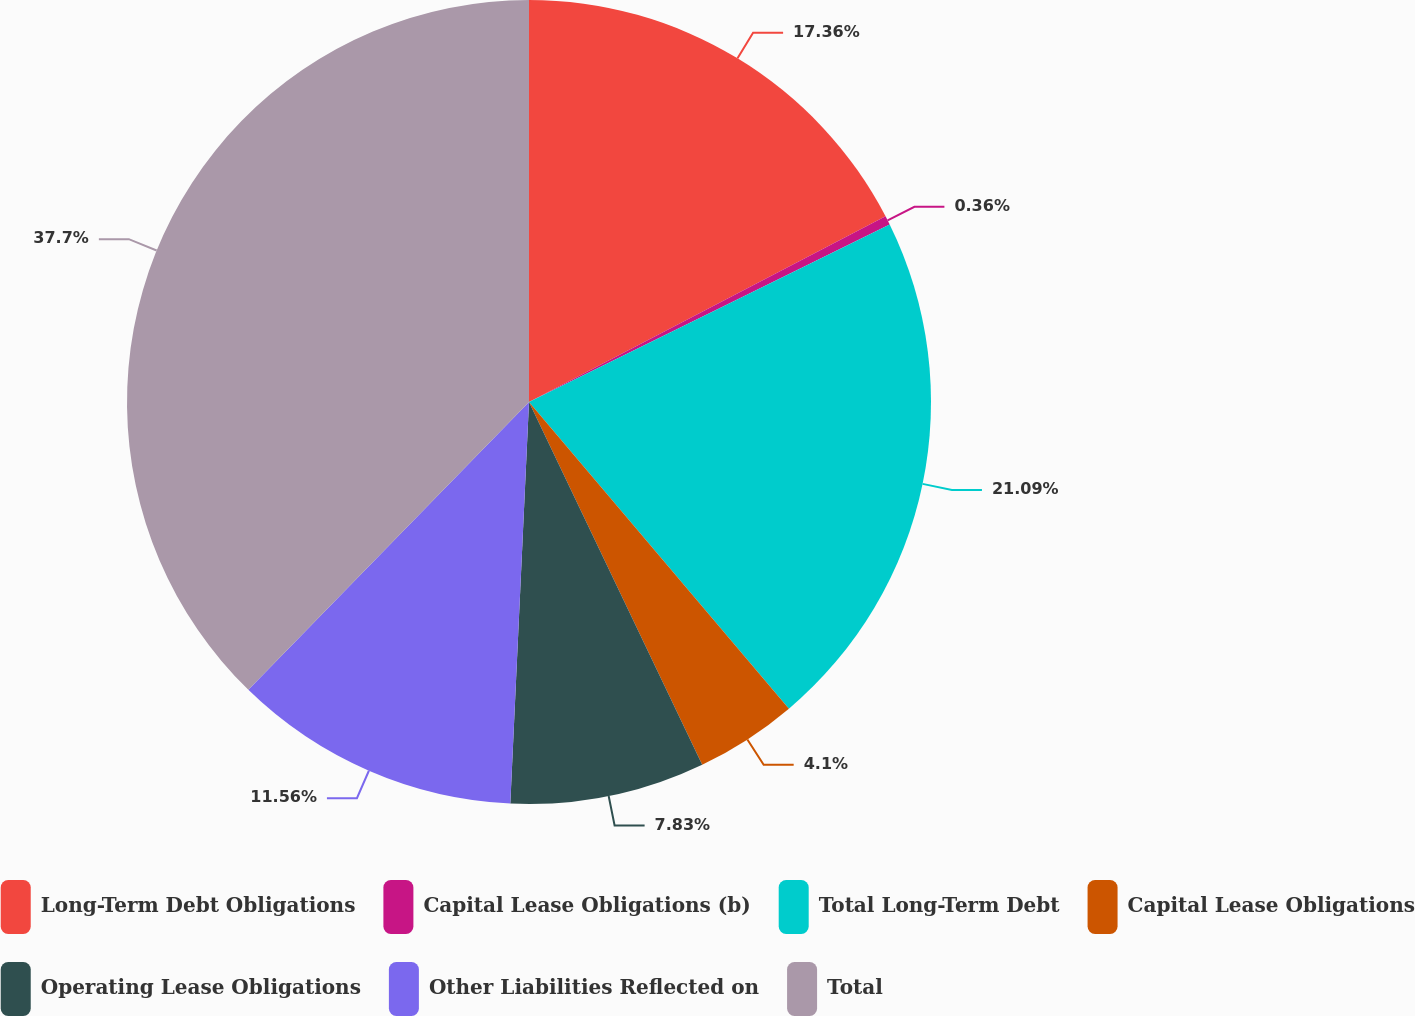Convert chart. <chart><loc_0><loc_0><loc_500><loc_500><pie_chart><fcel>Long-Term Debt Obligations<fcel>Capital Lease Obligations (b)<fcel>Total Long-Term Debt<fcel>Capital Lease Obligations<fcel>Operating Lease Obligations<fcel>Other Liabilities Reflected on<fcel>Total<nl><fcel>17.36%<fcel>0.36%<fcel>21.09%<fcel>4.1%<fcel>7.83%<fcel>11.56%<fcel>37.7%<nl></chart> 